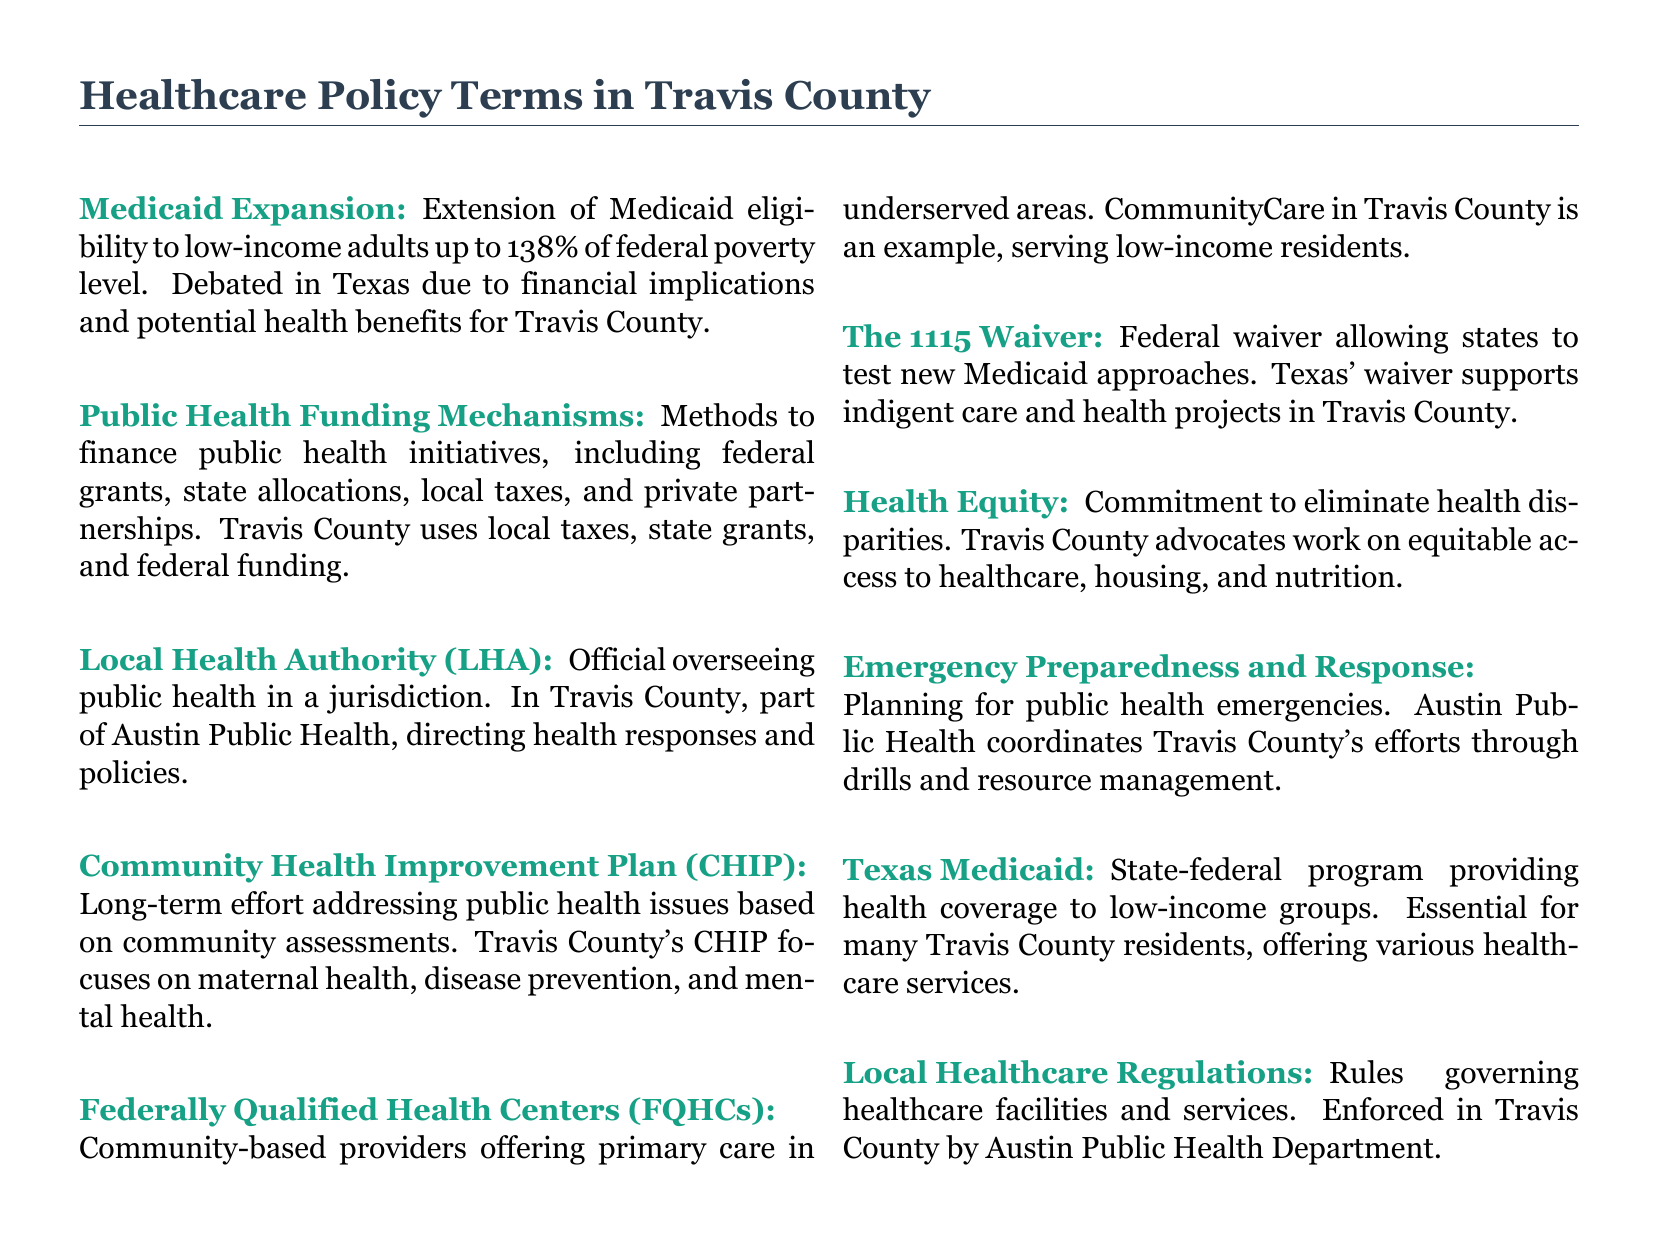What is Medicaid Expansion? Medicaid Expansion is defined as the extension of Medicaid eligibility to low-income adults up to 138% of federal poverty level.
Answer: Extension of Medicaid eligibility What does CHIP focus on in Travis County? The Community Health Improvement Plan (CHIP) focuses on addressing public health issues based on community assessments, specifically maternal health, disease prevention, and mental health in Travis County.
Answer: Maternal health, disease prevention, and mental health What is the role of the Local Health Authority (LHA)? The Local Health Authority (LHA) oversees public health in a jurisdiction, specifically directing health responses and policies in Travis County's Austin Public Health.
Answer: Overseeing public health What is a Federally Qualified Health Center (FQHC)? A Federally Qualified Health Center (FQHC) is a community-based provider offering primary care in underserved areas, such as CommunityCare in Travis County serving low-income residents.
Answer: Community-based provider What is the purpose of the 1115 Waiver? The 1115 Waiver is a federal waiver allowing states to test new Medicaid approaches, supporting indigent care and health projects in Texas, including Travis County.
Answer: Testing new Medicaid approaches What mechanisms finance public health initiatives in Travis County? Public health initiatives in Travis County are financed through methods including federal grants, state allocations, local taxes, and private partnerships.
Answer: Federal grants, state allocations, local taxes, private partnerships How does Travis County advocate for health equity? Travis County advocates for health equity to eliminate health disparities and works on providing equitable access to healthcare, housing, and nutrition.
Answer: Eliminate health disparities What department enforces local healthcare regulations in Travis County? Local healthcare regulations in Travis County are enforced by the Austin Public Health Department.
Answer: Austin Public Health Department 